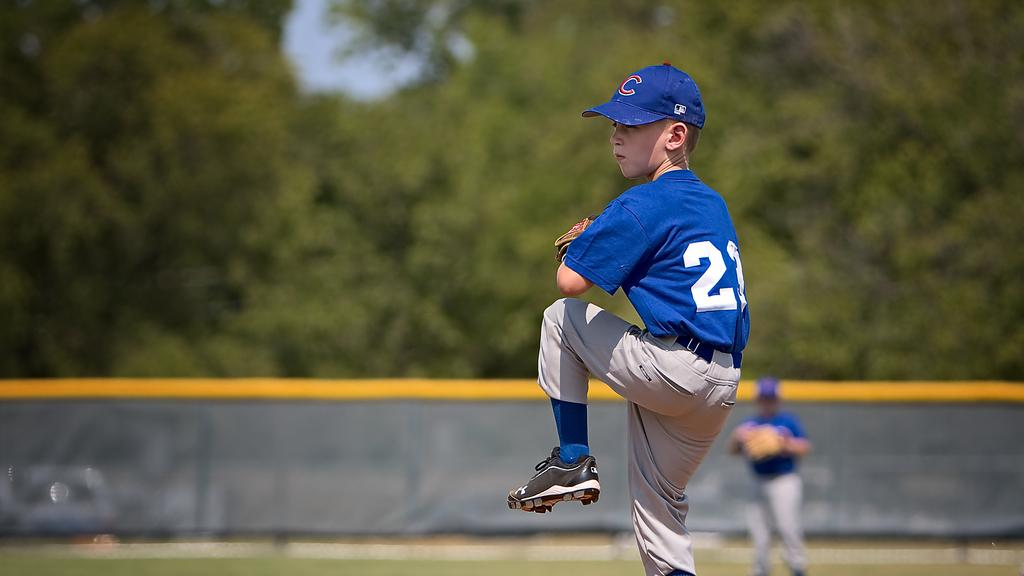<image>
Share a concise interpretation of the image provided. Player 23 was in the midst of throwing a pitch at the baseball game. 